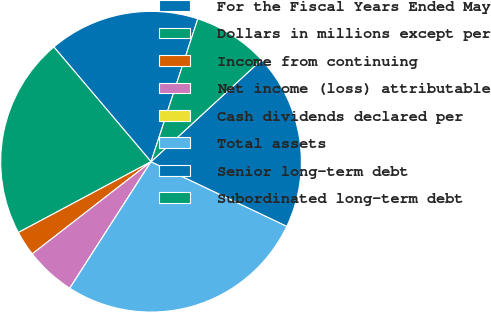Convert chart. <chart><loc_0><loc_0><loc_500><loc_500><pie_chart><fcel>For the Fiscal Years Ended May<fcel>Dollars in millions except per<fcel>Income from continuing<fcel>Net income (loss) attributable<fcel>Cash dividends declared per<fcel>Total assets<fcel>Senior long-term debt<fcel>Subordinated long-term debt<nl><fcel>16.22%<fcel>21.62%<fcel>2.7%<fcel>5.41%<fcel>0.0%<fcel>27.02%<fcel>18.92%<fcel>8.11%<nl></chart> 